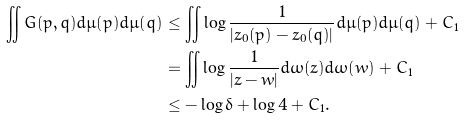<formula> <loc_0><loc_0><loc_500><loc_500>\iint G ( p , q ) d \mu ( p ) d \mu ( q ) & \leq \iint \log \frac { 1 } { | z _ { 0 } ( p ) - z _ { 0 } ( q ) | } d \mu ( p ) d \mu ( q ) + C _ { 1 } \\ & = \iint \log \frac { 1 } { | z - w | } d \omega ( z ) d \omega ( w ) + C _ { 1 } \\ & \leq - \log \delta + \log 4 + C _ { 1 } .</formula> 